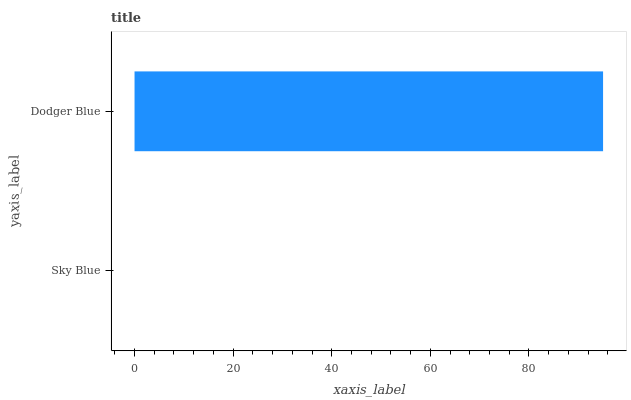Is Sky Blue the minimum?
Answer yes or no. Yes. Is Dodger Blue the maximum?
Answer yes or no. Yes. Is Dodger Blue the minimum?
Answer yes or no. No. Is Dodger Blue greater than Sky Blue?
Answer yes or no. Yes. Is Sky Blue less than Dodger Blue?
Answer yes or no. Yes. Is Sky Blue greater than Dodger Blue?
Answer yes or no. No. Is Dodger Blue less than Sky Blue?
Answer yes or no. No. Is Dodger Blue the high median?
Answer yes or no. Yes. Is Sky Blue the low median?
Answer yes or no. Yes. Is Sky Blue the high median?
Answer yes or no. No. Is Dodger Blue the low median?
Answer yes or no. No. 